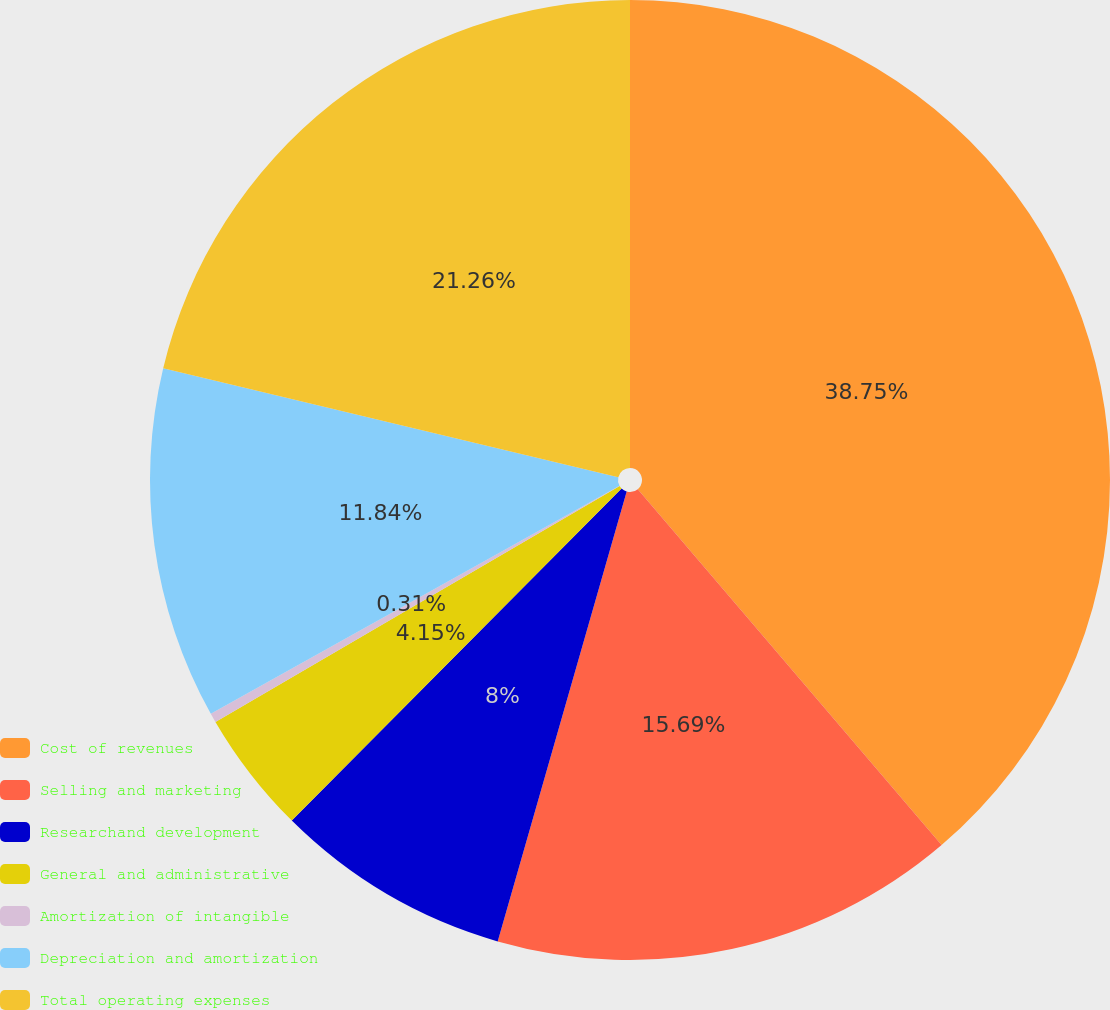Convert chart to OTSL. <chart><loc_0><loc_0><loc_500><loc_500><pie_chart><fcel>Cost of revenues<fcel>Selling and marketing<fcel>Researchand development<fcel>General and administrative<fcel>Amortization of intangible<fcel>Depreciation and amortization<fcel>Total operating expenses<nl><fcel>38.76%<fcel>15.69%<fcel>8.0%<fcel>4.15%<fcel>0.31%<fcel>11.84%<fcel>21.26%<nl></chart> 